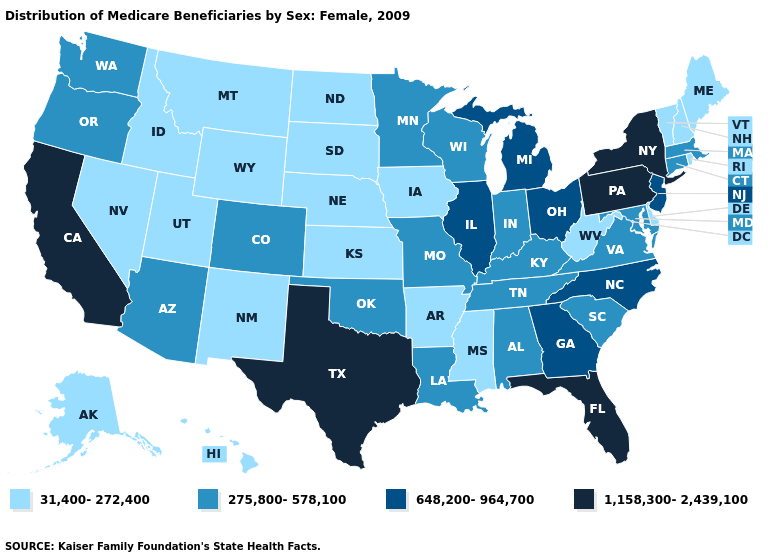Does Ohio have the lowest value in the MidWest?
Answer briefly. No. What is the value of Arizona?
Short answer required. 275,800-578,100. What is the value of Virginia?
Be succinct. 275,800-578,100. Is the legend a continuous bar?
Short answer required. No. What is the value of Tennessee?
Concise answer only. 275,800-578,100. Among the states that border Louisiana , does Arkansas have the lowest value?
Be succinct. Yes. Name the states that have a value in the range 648,200-964,700?
Keep it brief. Georgia, Illinois, Michigan, New Jersey, North Carolina, Ohio. Which states hav the highest value in the MidWest?
Concise answer only. Illinois, Michigan, Ohio. Does the map have missing data?
Concise answer only. No. Name the states that have a value in the range 31,400-272,400?
Be succinct. Alaska, Arkansas, Delaware, Hawaii, Idaho, Iowa, Kansas, Maine, Mississippi, Montana, Nebraska, Nevada, New Hampshire, New Mexico, North Dakota, Rhode Island, South Dakota, Utah, Vermont, West Virginia, Wyoming. Does New York have the highest value in the USA?
Concise answer only. Yes. Name the states that have a value in the range 31,400-272,400?
Answer briefly. Alaska, Arkansas, Delaware, Hawaii, Idaho, Iowa, Kansas, Maine, Mississippi, Montana, Nebraska, Nevada, New Hampshire, New Mexico, North Dakota, Rhode Island, South Dakota, Utah, Vermont, West Virginia, Wyoming. Among the states that border Texas , does Oklahoma have the lowest value?
Be succinct. No. What is the value of New York?
Give a very brief answer. 1,158,300-2,439,100. What is the value of New York?
Be succinct. 1,158,300-2,439,100. 